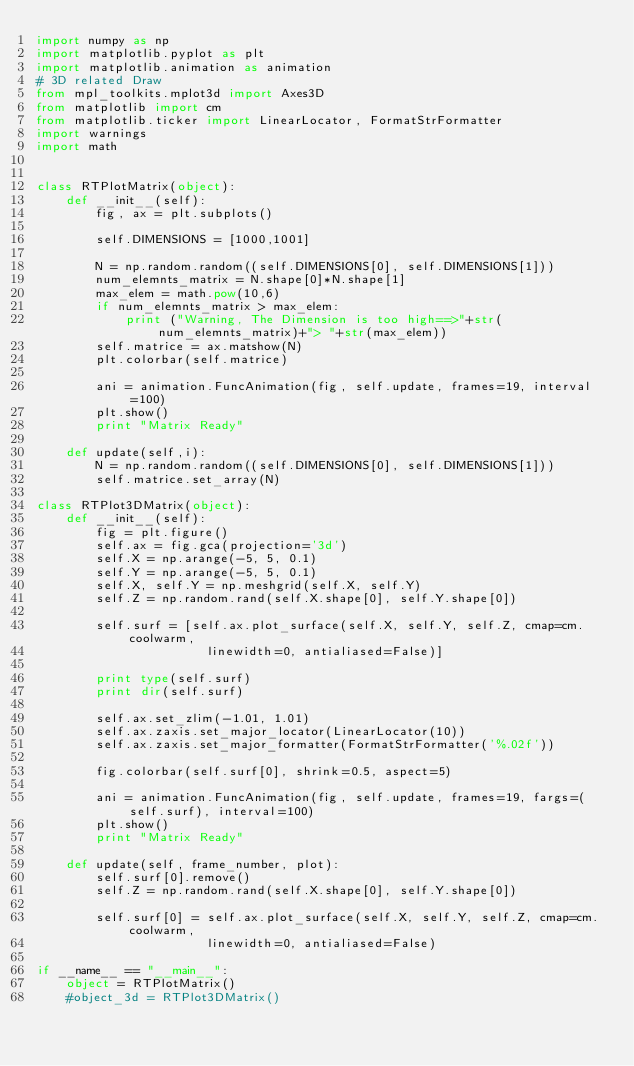<code> <loc_0><loc_0><loc_500><loc_500><_Python_>import numpy as np
import matplotlib.pyplot as plt
import matplotlib.animation as animation
# 3D related Draw
from mpl_toolkits.mplot3d import Axes3D
from matplotlib import cm
from matplotlib.ticker import LinearLocator, FormatStrFormatter
import warnings
import math


class RTPlotMatrix(object):
    def __init__(self):
        fig, ax = plt.subplots()

        self.DIMENSIONS = [1000,1001]

        N = np.random.random((self.DIMENSIONS[0], self.DIMENSIONS[1]))
        num_elemnts_matrix = N.shape[0]*N.shape[1]
        max_elem = math.pow(10,6)
        if num_elemnts_matrix > max_elem:
            print ("Warning, The Dimension is too high==>"+str(num_elemnts_matrix)+"> "+str(max_elem))
        self.matrice = ax.matshow(N)
        plt.colorbar(self.matrice)

        ani = animation.FuncAnimation(fig, self.update, frames=19, interval=100)
        plt.show()
        print "Matrix Ready"

    def update(self,i):
        N = np.random.random((self.DIMENSIONS[0], self.DIMENSIONS[1]))
        self.matrice.set_array(N)

class RTPlot3DMatrix(object):
    def __init__(self):
        fig = plt.figure()
        self.ax = fig.gca(projection='3d')
        self.X = np.arange(-5, 5, 0.1)
        self.Y = np.arange(-5, 5, 0.1)
        self.X, self.Y = np.meshgrid(self.X, self.Y)
        self.Z = np.random.rand(self.X.shape[0], self.Y.shape[0])

        self.surf = [self.ax.plot_surface(self.X, self.Y, self.Z, cmap=cm.coolwarm,
                       linewidth=0, antialiased=False)]

        print type(self.surf)
        print dir(self.surf)

        self.ax.set_zlim(-1.01, 1.01)
        self.ax.zaxis.set_major_locator(LinearLocator(10))
        self.ax.zaxis.set_major_formatter(FormatStrFormatter('%.02f'))

        fig.colorbar(self.surf[0], shrink=0.5, aspect=5)

        ani = animation.FuncAnimation(fig, self.update, frames=19, fargs=(self.surf), interval=100)
        plt.show()
        print "Matrix Ready"

    def update(self, frame_number, plot):
        self.surf[0].remove()
        self.Z = np.random.rand(self.X.shape[0], self.Y.shape[0])

        self.surf[0] = self.ax.plot_surface(self.X, self.Y, self.Z, cmap=cm.coolwarm,
                       linewidth=0, antialiased=False)

if __name__ == "__main__":
    object = RTPlotMatrix()
    #object_3d = RTPlot3DMatrix()
</code> 